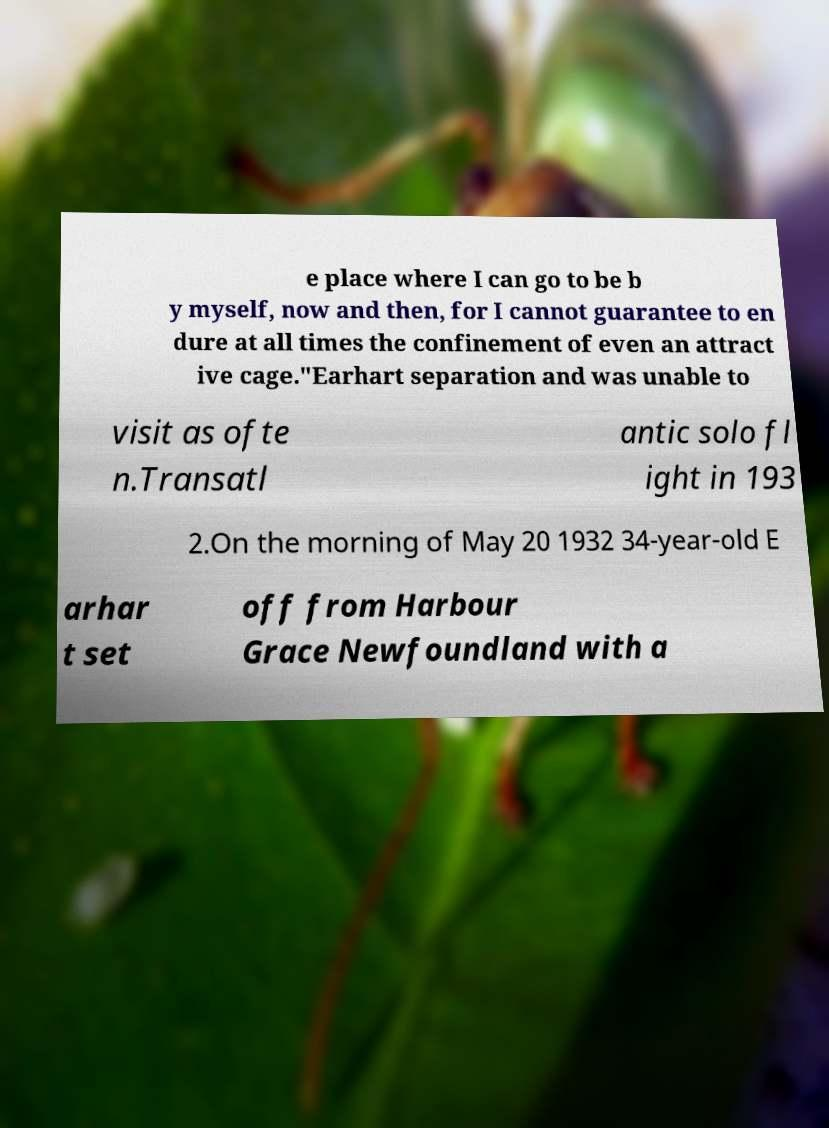Could you assist in decoding the text presented in this image and type it out clearly? e place where I can go to be b y myself, now and then, for I cannot guarantee to en dure at all times the confinement of even an attract ive cage."Earhart separation and was unable to visit as ofte n.Transatl antic solo fl ight in 193 2.On the morning of May 20 1932 34-year-old E arhar t set off from Harbour Grace Newfoundland with a 